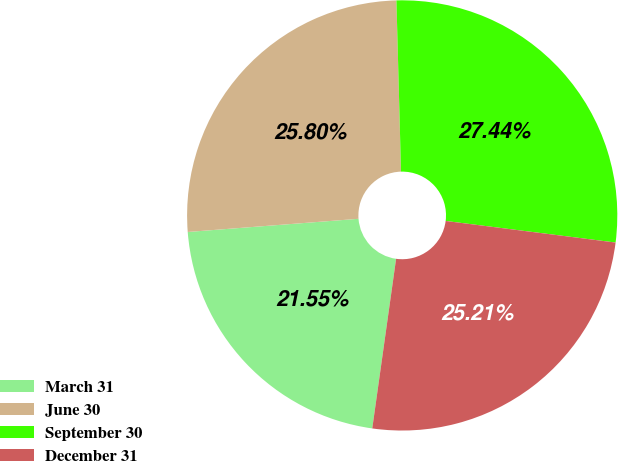<chart> <loc_0><loc_0><loc_500><loc_500><pie_chart><fcel>March 31<fcel>June 30<fcel>September 30<fcel>December 31<nl><fcel>21.55%<fcel>25.8%<fcel>27.44%<fcel>25.21%<nl></chart> 